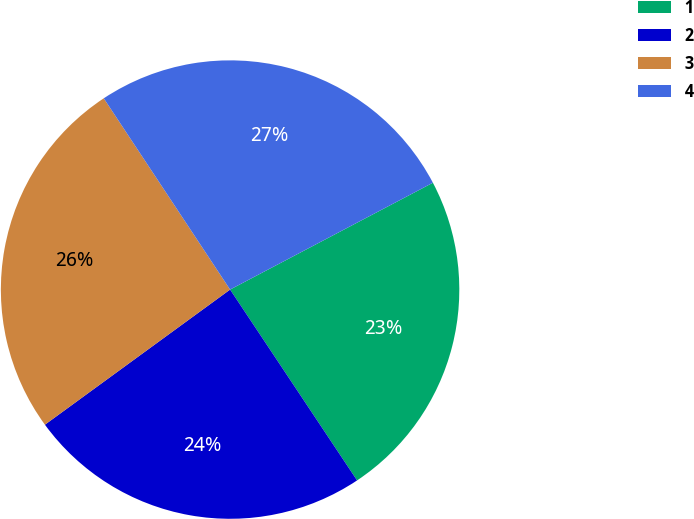Convert chart. <chart><loc_0><loc_0><loc_500><loc_500><pie_chart><fcel>1<fcel>2<fcel>3<fcel>4<nl><fcel>23.37%<fcel>24.31%<fcel>25.74%<fcel>26.57%<nl></chart> 